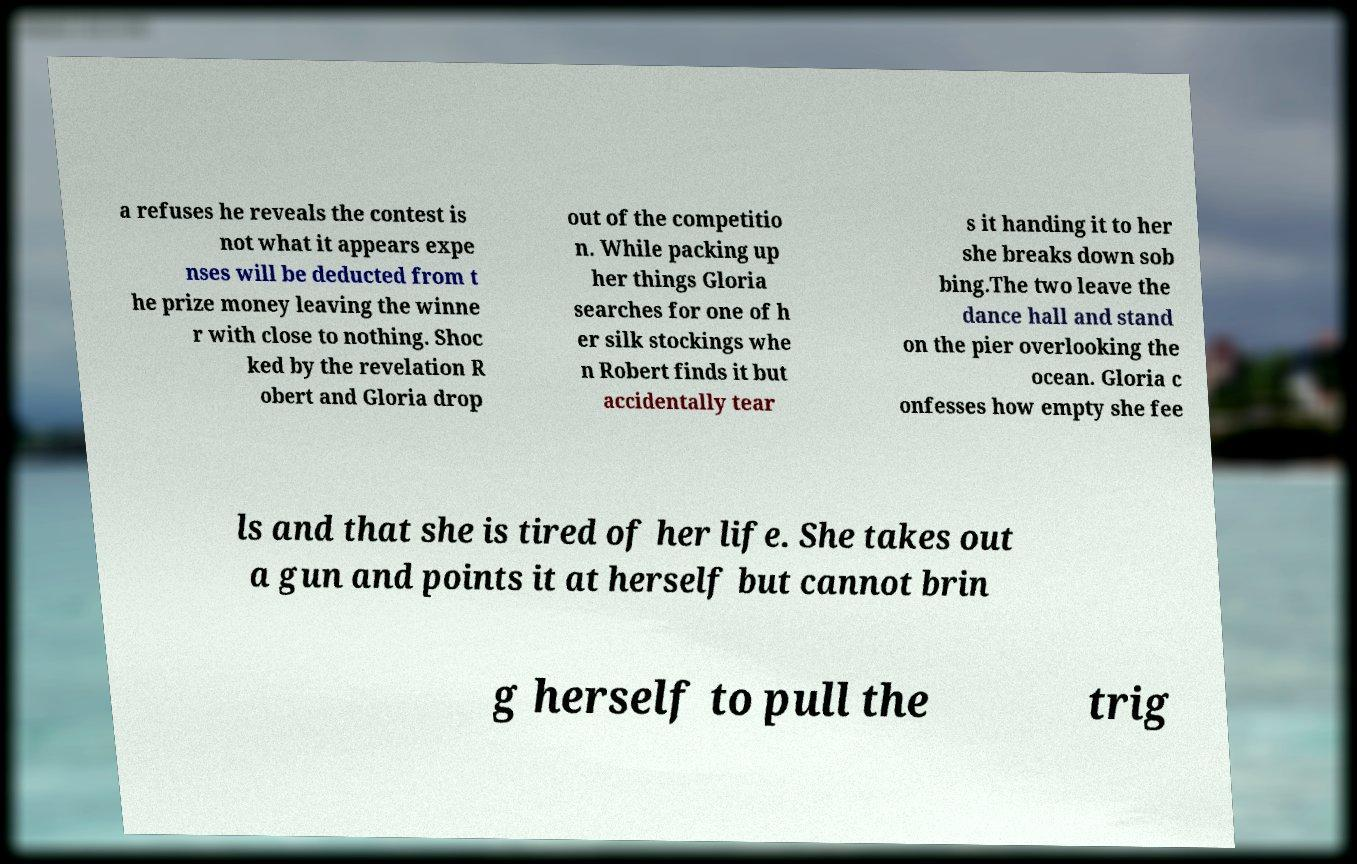Could you assist in decoding the text presented in this image and type it out clearly? a refuses he reveals the contest is not what it appears expe nses will be deducted from t he prize money leaving the winne r with close to nothing. Shoc ked by the revelation R obert and Gloria drop out of the competitio n. While packing up her things Gloria searches for one of h er silk stockings whe n Robert finds it but accidentally tear s it handing it to her she breaks down sob bing.The two leave the dance hall and stand on the pier overlooking the ocean. Gloria c onfesses how empty she fee ls and that she is tired of her life. She takes out a gun and points it at herself but cannot brin g herself to pull the trig 